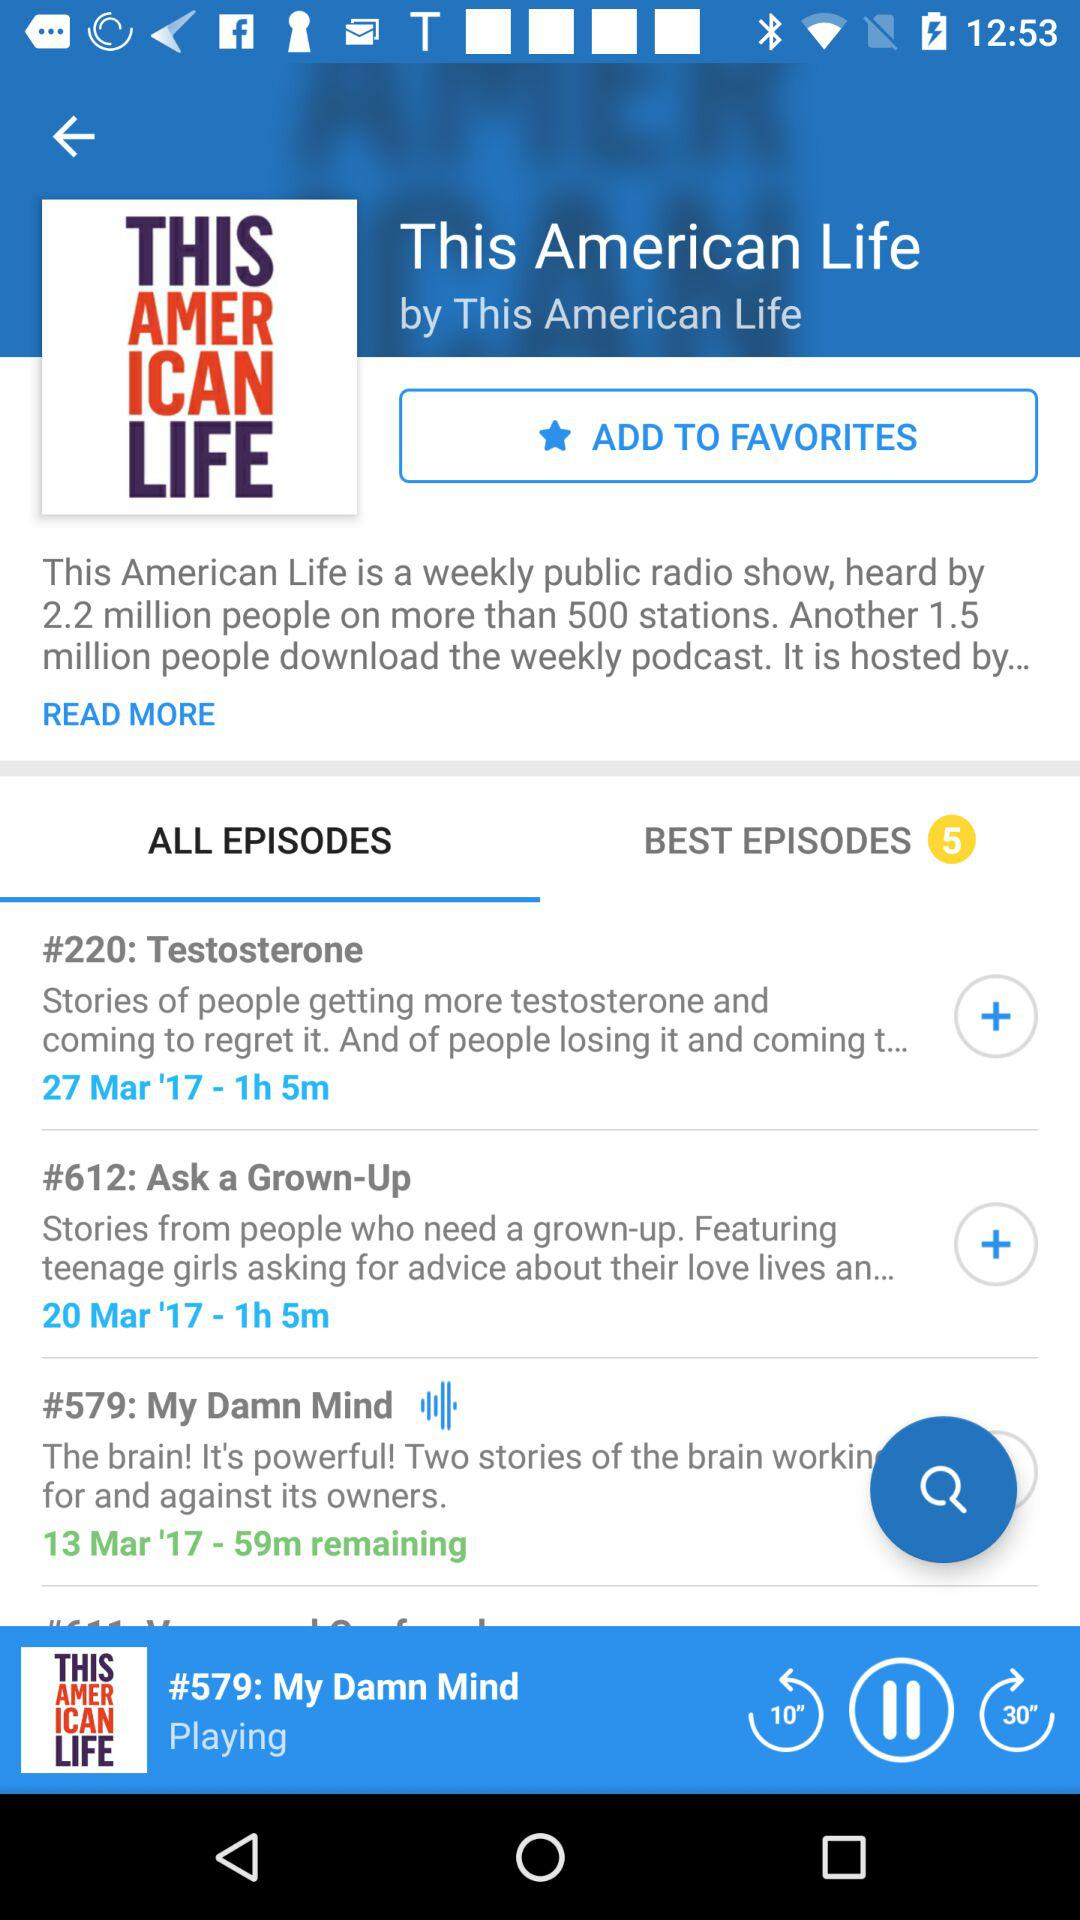Who is the host of the "This American Life" show? The host of the "This American Life" show is "This American Life". 